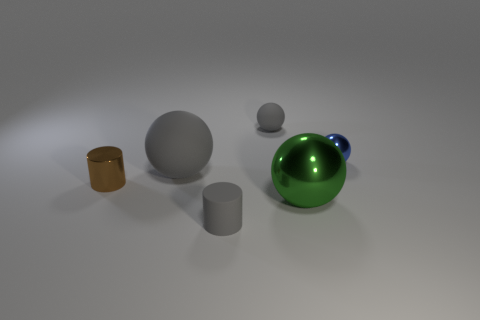Subtract all tiny shiny spheres. How many spheres are left? 3 Add 3 big yellow shiny objects. How many objects exist? 9 Subtract all cylinders. How many objects are left? 4 Subtract all brown cylinders. How many cylinders are left? 1 Subtract all cyan balls. Subtract all gray cylinders. How many balls are left? 4 Subtract all purple cubes. How many gray spheres are left? 2 Subtract all tiny blue spheres. Subtract all large brown metallic objects. How many objects are left? 5 Add 5 small shiny spheres. How many small shiny spheres are left? 6 Add 4 large matte objects. How many large matte objects exist? 5 Subtract 1 gray cylinders. How many objects are left? 5 